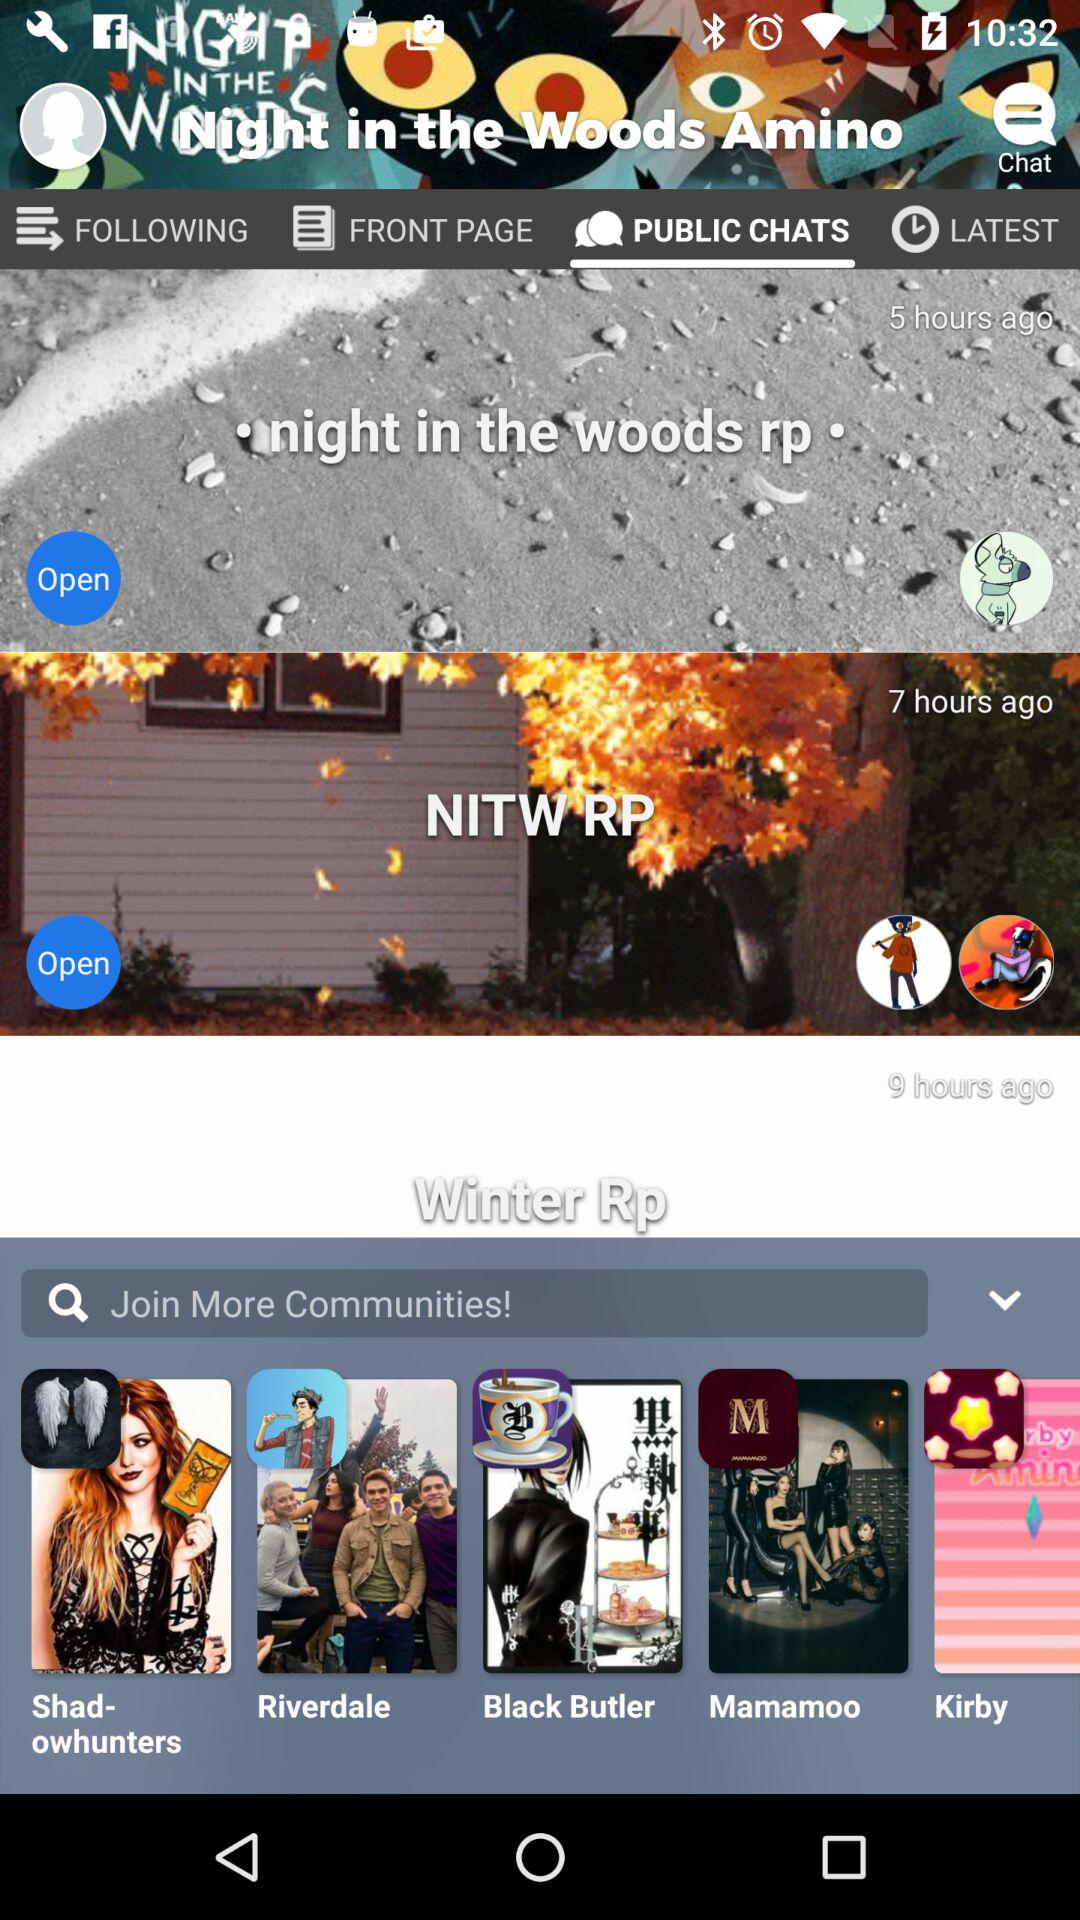Which tab is selected? The selected tab is "PUBLIC CHATS". 